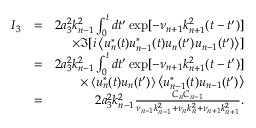<formula> <loc_0><loc_0><loc_500><loc_500>\begin{array} { r l r } { I _ { 3 } } & { = } & { 2 a _ { 3 } ^ { 2 } k _ { n - 1 } ^ { 2 } \int _ { 0 } ^ { t } d t ^ { \prime } \exp [ - \nu _ { n + 1 } k _ { n + 1 } ^ { 2 } ( t - t ^ { \prime } ) ] } \\ & { \times \Im [ i \left \langle u _ { n } ^ { * } ( t ) u _ { n - 1 } ^ { * } ( t ) u _ { n } ( t ^ { \prime } ) u _ { n - 1 } ( t ^ { \prime } ) \right \rangle ] } \\ & { = } & { 2 a _ { 3 } ^ { 2 } k _ { n - 1 } ^ { 2 } \int _ { 0 } ^ { t } d t ^ { \prime } \exp [ - \nu _ { n + 1 } k _ { n + 1 } ^ { 2 } ( t - t ^ { \prime } ) ] } \\ & { \times \left \langle u _ { n } ^ { * } ( t ) u _ { n } ( t ^ { \prime } ) \right \rangle \left \langle u _ { n - 1 } ^ { * } ( t ) u _ { n - 1 } ( t ^ { \prime } ) \right \rangle } \\ & { = } & { 2 a _ { 3 } ^ { 2 } k _ { n - 1 } ^ { 2 } \frac { C _ { n } C _ { n - 1 } } { \nu _ { n - 1 } k _ { n - 1 } ^ { 2 } + \nu _ { n } k _ { n } ^ { 2 } + \nu _ { n + 1 } k _ { n + 1 } ^ { 2 } } . } \end{array}</formula> 